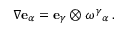Convert formula to latex. <formula><loc_0><loc_0><loc_500><loc_500>\nabla e _ { \alpha } = e _ { \gamma } \otimes \omega ^ { \gamma _ { \alpha } \, .</formula> 